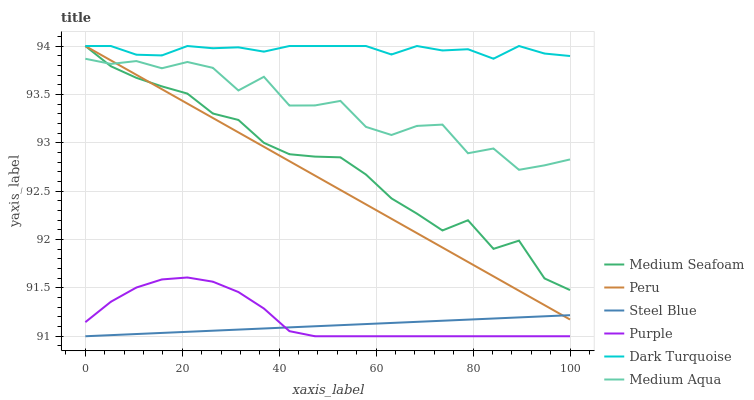Does Dark Turquoise have the minimum area under the curve?
Answer yes or no. No. Does Steel Blue have the maximum area under the curve?
Answer yes or no. No. Is Dark Turquoise the smoothest?
Answer yes or no. No. Is Dark Turquoise the roughest?
Answer yes or no. No. Does Dark Turquoise have the lowest value?
Answer yes or no. No. Does Steel Blue have the highest value?
Answer yes or no. No. Is Purple less than Dark Turquoise?
Answer yes or no. Yes. Is Dark Turquoise greater than Medium Aqua?
Answer yes or no. Yes. Does Purple intersect Dark Turquoise?
Answer yes or no. No. 